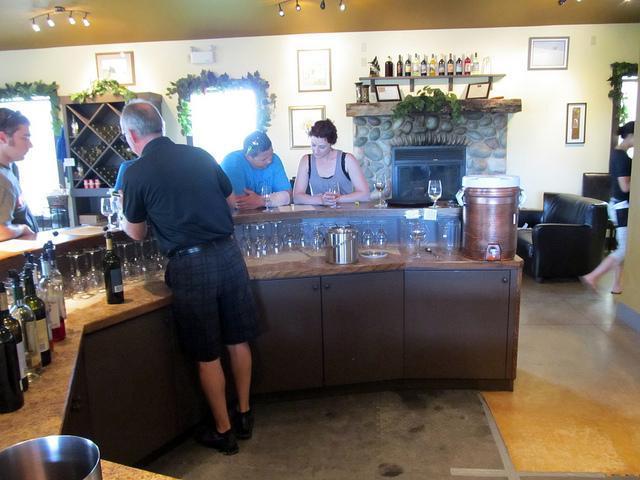How many bottles on the bar?
Give a very brief answer. 7. How many people are there?
Give a very brief answer. 5. 